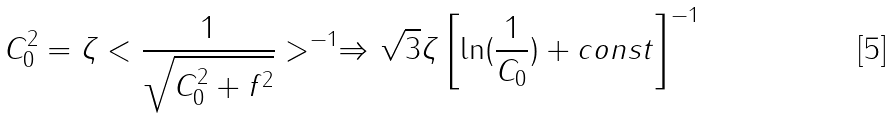<formula> <loc_0><loc_0><loc_500><loc_500>C _ { 0 } ^ { 2 } = \zeta < \frac { 1 } { \sqrt { C _ { 0 } ^ { 2 } + f ^ { 2 } } } > ^ { - 1 } \Rightarrow \sqrt { 3 } \zeta \left [ \ln ( \frac { 1 } { C _ { 0 } } ) + c o n s t \right ] ^ { - 1 }</formula> 